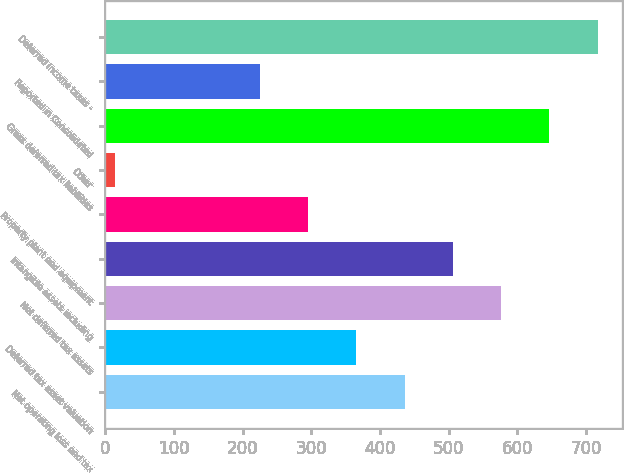Convert chart to OTSL. <chart><loc_0><loc_0><loc_500><loc_500><bar_chart><fcel>Net operating loss and tax<fcel>Deferred tax asset valuation<fcel>Net deferred tax assets<fcel>Intangible assets including<fcel>Property plant and equipment<fcel>Other<fcel>Gross deferred tax liabilities<fcel>Reported in Consolidated<fcel>Deferred income taxes -<nl><fcel>435.8<fcel>365.5<fcel>576.4<fcel>506.1<fcel>295.2<fcel>14<fcel>646.7<fcel>224.9<fcel>717<nl></chart> 